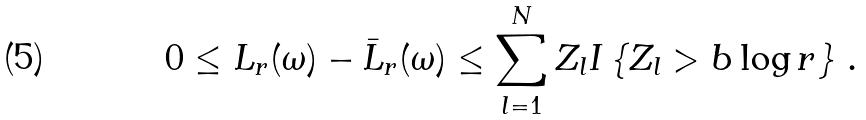<formula> <loc_0><loc_0><loc_500><loc_500>0 \leq L _ { r } ( \omega ) - \bar { L } _ { r } ( \omega ) \leq \sum _ { l = 1 } ^ { N } Z _ { l } I \left \{ Z _ { l } > b \log r \right \} \, .</formula> 